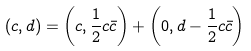<formula> <loc_0><loc_0><loc_500><loc_500>( c , d ) = \left ( c , \frac { 1 } { 2 } c \bar { c } \right ) + \left ( 0 , d - \frac { 1 } { 2 } c \bar { c } \right )</formula> 